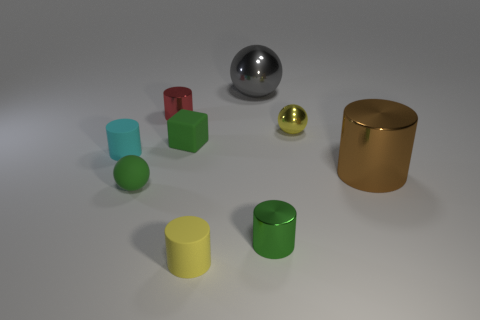Is there a ball that has the same size as the yellow cylinder?
Make the answer very short. Yes. What is the material of the yellow cylinder that is the same size as the cyan thing?
Give a very brief answer. Rubber. There is a big thing that is behind the green cube; what is its shape?
Keep it short and to the point. Sphere. Are the tiny thing that is in front of the small green metal cylinder and the block behind the green metallic cylinder made of the same material?
Your answer should be compact. Yes. What number of yellow objects are the same shape as the gray thing?
Give a very brief answer. 1. There is a small cylinder that is the same color as the tiny rubber sphere; what material is it?
Keep it short and to the point. Metal. How many objects are yellow cylinders or things in front of the tiny red metal thing?
Your answer should be compact. 7. What material is the small cyan thing?
Give a very brief answer. Rubber. What material is the yellow thing that is the same shape as the brown object?
Ensure brevity in your answer.  Rubber. What is the color of the small metallic cylinder behind the tiny green rubber object behind the brown metal object?
Offer a very short reply. Red. 